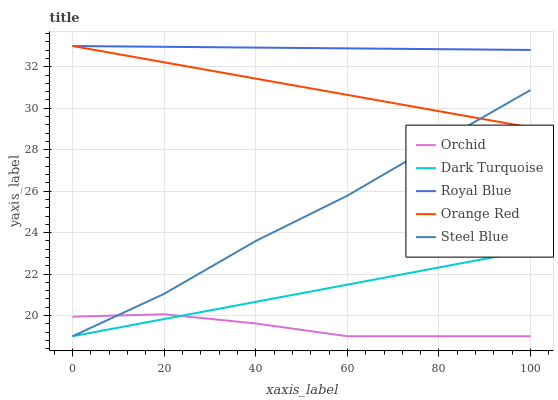Does Orchid have the minimum area under the curve?
Answer yes or no. Yes. Does Royal Blue have the maximum area under the curve?
Answer yes or no. Yes. Does Steel Blue have the minimum area under the curve?
Answer yes or no. No. Does Steel Blue have the maximum area under the curve?
Answer yes or no. No. Is Orange Red the smoothest?
Answer yes or no. Yes. Is Orchid the roughest?
Answer yes or no. Yes. Is Steel Blue the smoothest?
Answer yes or no. No. Is Steel Blue the roughest?
Answer yes or no. No. Does Dark Turquoise have the lowest value?
Answer yes or no. Yes. Does Orange Red have the lowest value?
Answer yes or no. No. Does Royal Blue have the highest value?
Answer yes or no. Yes. Does Steel Blue have the highest value?
Answer yes or no. No. Is Orchid less than Royal Blue?
Answer yes or no. Yes. Is Royal Blue greater than Orchid?
Answer yes or no. Yes. Does Steel Blue intersect Orchid?
Answer yes or no. Yes. Is Steel Blue less than Orchid?
Answer yes or no. No. Is Steel Blue greater than Orchid?
Answer yes or no. No. Does Orchid intersect Royal Blue?
Answer yes or no. No. 